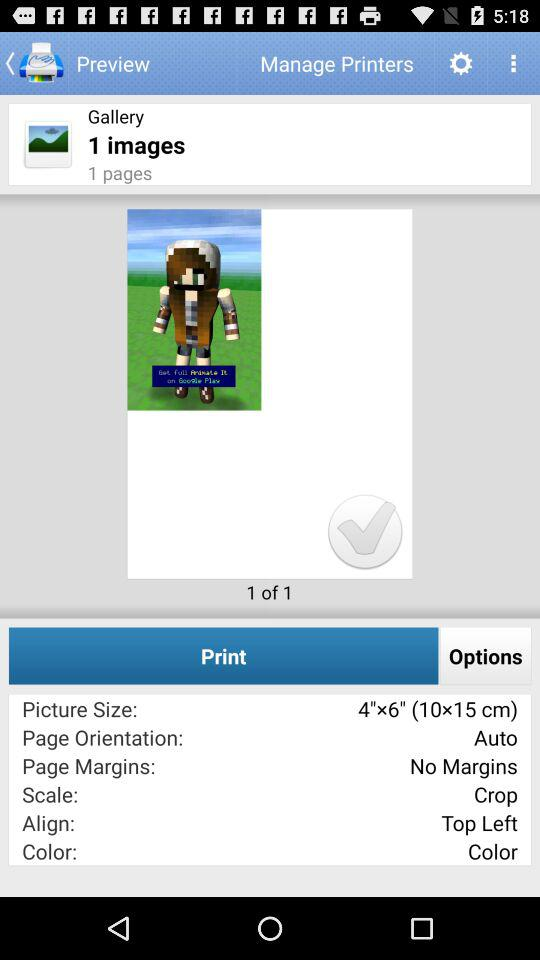How many pages are there in the preview?
Answer the question using a single word or phrase. 1 